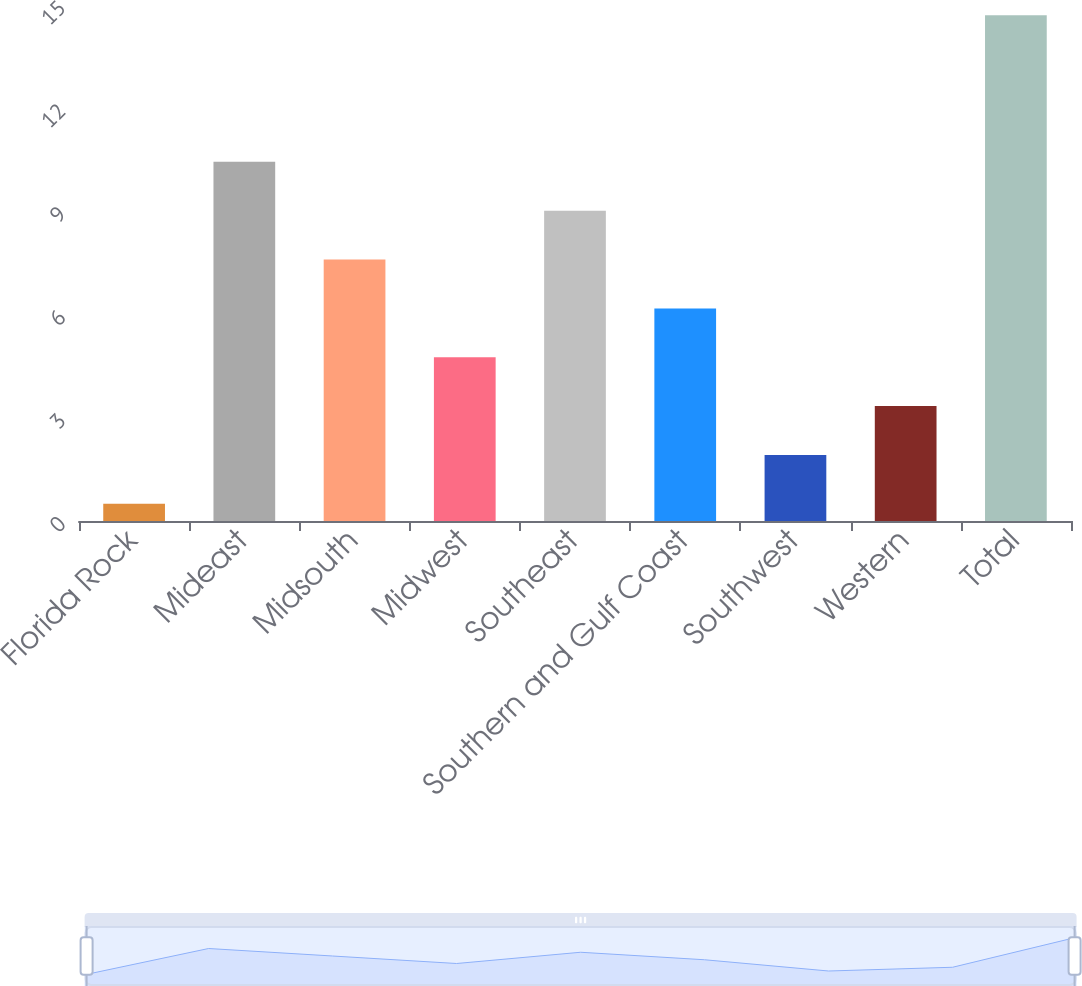Convert chart. <chart><loc_0><loc_0><loc_500><loc_500><bar_chart><fcel>Florida Rock<fcel>Mideast<fcel>Midsouth<fcel>Midwest<fcel>Southeast<fcel>Southern and Gulf Coast<fcel>Southwest<fcel>Western<fcel>Total<nl><fcel>0.5<fcel>10.44<fcel>7.6<fcel>4.76<fcel>9.02<fcel>6.18<fcel>1.92<fcel>3.34<fcel>14.7<nl></chart> 